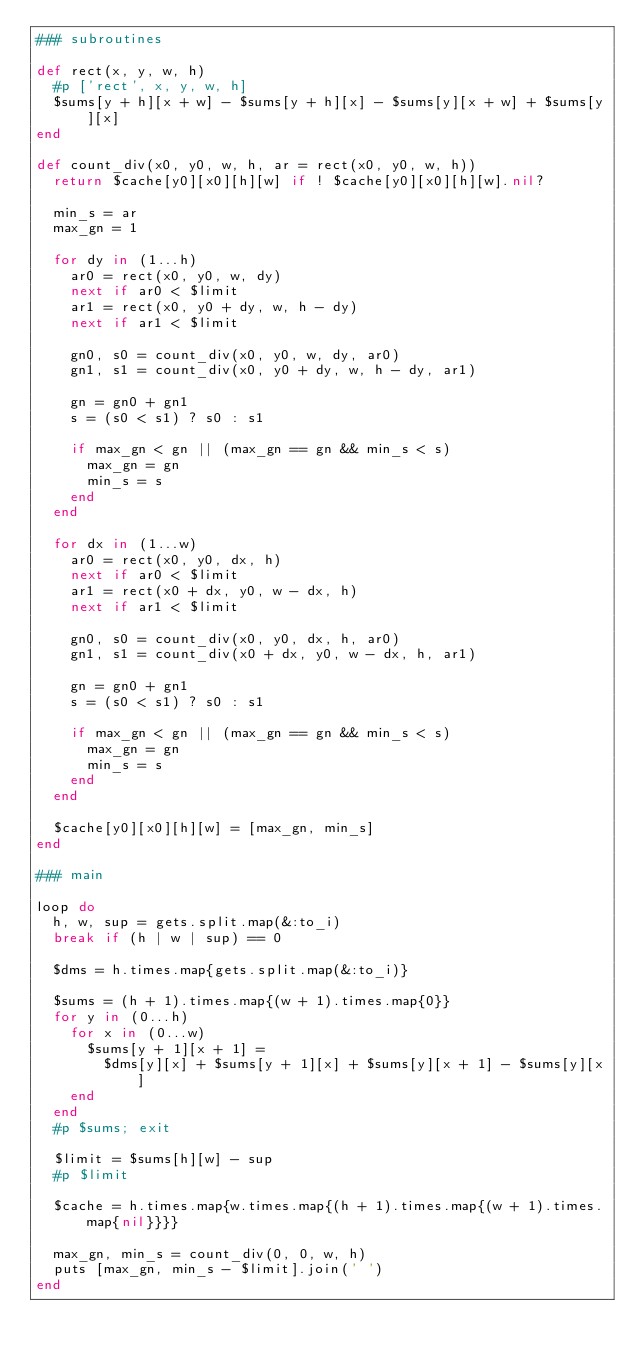Convert code to text. <code><loc_0><loc_0><loc_500><loc_500><_Ruby_>### subroutines

def rect(x, y, w, h)
  #p ['rect', x, y, w, h]
  $sums[y + h][x + w] - $sums[y + h][x] - $sums[y][x + w] + $sums[y][x]
end

def count_div(x0, y0, w, h, ar = rect(x0, y0, w, h))
  return $cache[y0][x0][h][w] if ! $cache[y0][x0][h][w].nil?

  min_s = ar
  max_gn = 1

  for dy in (1...h)
    ar0 = rect(x0, y0, w, dy)
    next if ar0 < $limit
    ar1 = rect(x0, y0 + dy, w, h - dy)
    next if ar1 < $limit

    gn0, s0 = count_div(x0, y0, w, dy, ar0)
    gn1, s1 = count_div(x0, y0 + dy, w, h - dy, ar1)

    gn = gn0 + gn1
    s = (s0 < s1) ? s0 : s1

    if max_gn < gn || (max_gn == gn && min_s < s)
      max_gn = gn
      min_s = s
    end    
  end

  for dx in (1...w)
    ar0 = rect(x0, y0, dx, h)
    next if ar0 < $limit
    ar1 = rect(x0 + dx, y0, w - dx, h)
    next if ar1 < $limit

    gn0, s0 = count_div(x0, y0, dx, h, ar0)
    gn1, s1 = count_div(x0 + dx, y0, w - dx, h, ar1)

    gn = gn0 + gn1
    s = (s0 < s1) ? s0 : s1

    if max_gn < gn || (max_gn == gn && min_s < s)
      max_gn = gn
      min_s = s
    end    
  end

  $cache[y0][x0][h][w] = [max_gn, min_s]
end

### main

loop do
  h, w, sup = gets.split.map(&:to_i)
  break if (h | w | sup) == 0

  $dms = h.times.map{gets.split.map(&:to_i)}

  $sums = (h + 1).times.map{(w + 1).times.map{0}}
  for y in (0...h)
    for x in (0...w)
      $sums[y + 1][x + 1] =
        $dms[y][x] + $sums[y + 1][x] + $sums[y][x + 1] - $sums[y][x]
    end
  end
  #p $sums; exit

  $limit = $sums[h][w] - sup
  #p $limit
  
  $cache = h.times.map{w.times.map{(h + 1).times.map{(w + 1).times.map{nil}}}}

  max_gn, min_s = count_div(0, 0, w, h)
  puts [max_gn, min_s - $limit].join(' ')
end</code> 